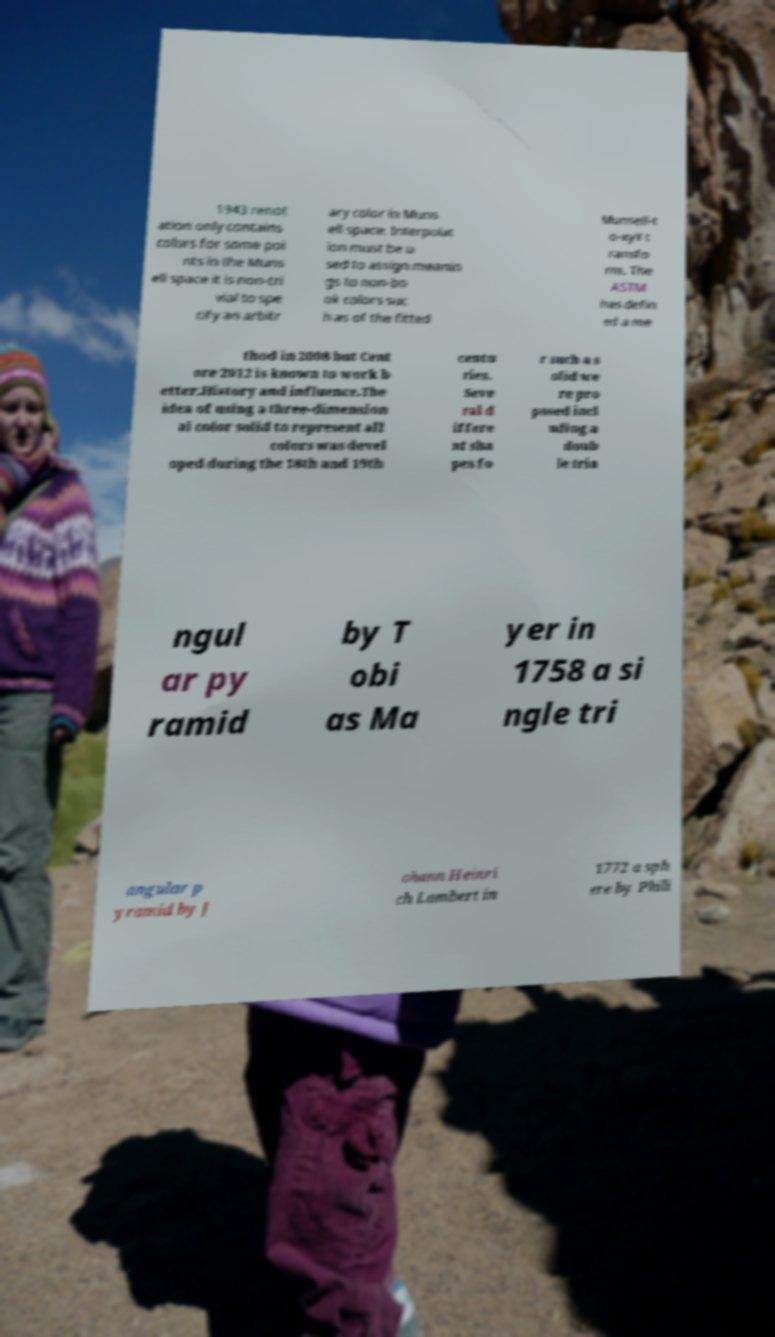Can you accurately transcribe the text from the provided image for me? 1943 renot ation only contains colors for some poi nts in the Muns ell space it is non-tri vial to spe cify an arbitr ary color in Muns ell space. Interpolat ion must be u sed to assign meanin gs to non-bo ok colors suc h as of the fitted Munsell-t o-xyY t ransfo rm. The ASTM has defin ed a me thod in 2008 but Cent ore 2012 is known to work b etter.History and influence.The idea of using a three-dimension al color solid to represent all colors was devel oped during the 18th and 19th centu ries. Seve ral d iffere nt sha pes fo r such a s olid we re pro posed incl uding a doub le tria ngul ar py ramid by T obi as Ma yer in 1758 a si ngle tri angular p yramid by J ohann Heinri ch Lambert in 1772 a sph ere by Phili 